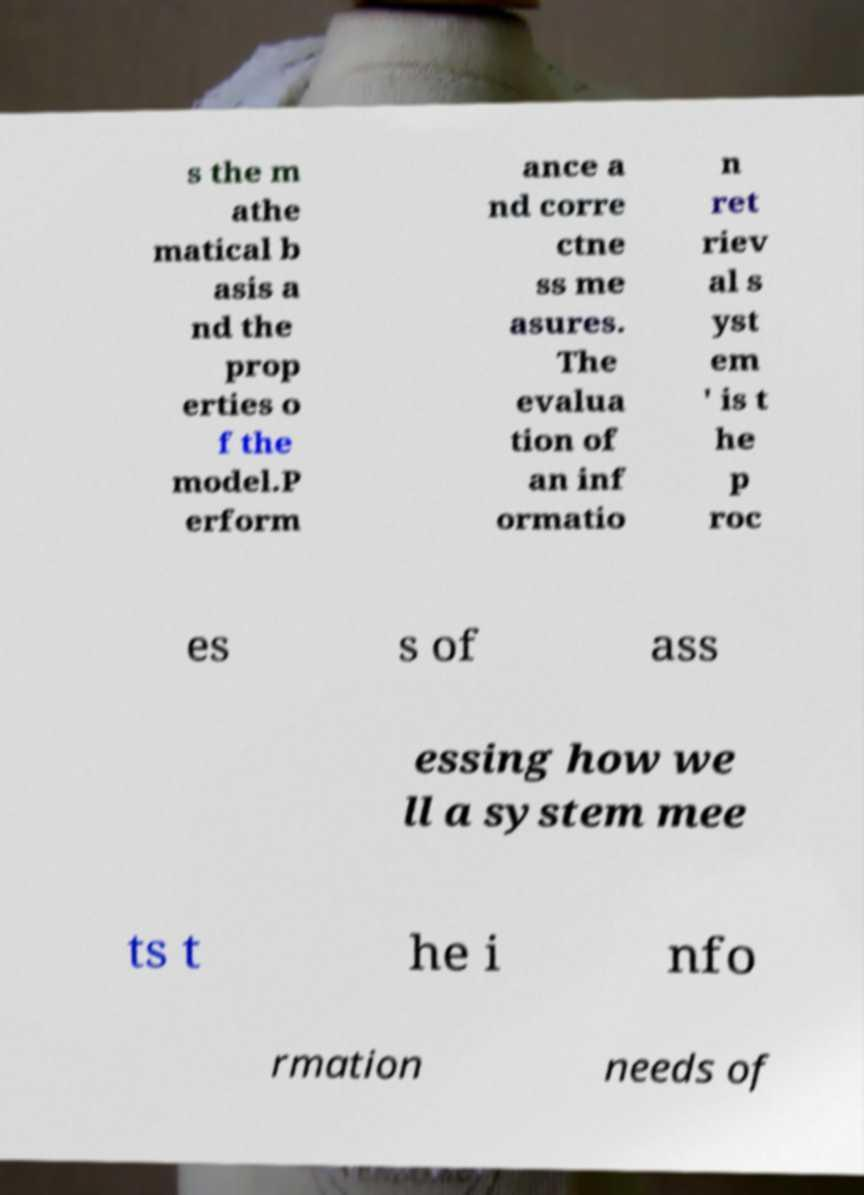What messages or text are displayed in this image? I need them in a readable, typed format. s the m athe matical b asis a nd the prop erties o f the model.P erform ance a nd corre ctne ss me asures. The evalua tion of an inf ormatio n ret riev al s yst em ' is t he p roc es s of ass essing how we ll a system mee ts t he i nfo rmation needs of 